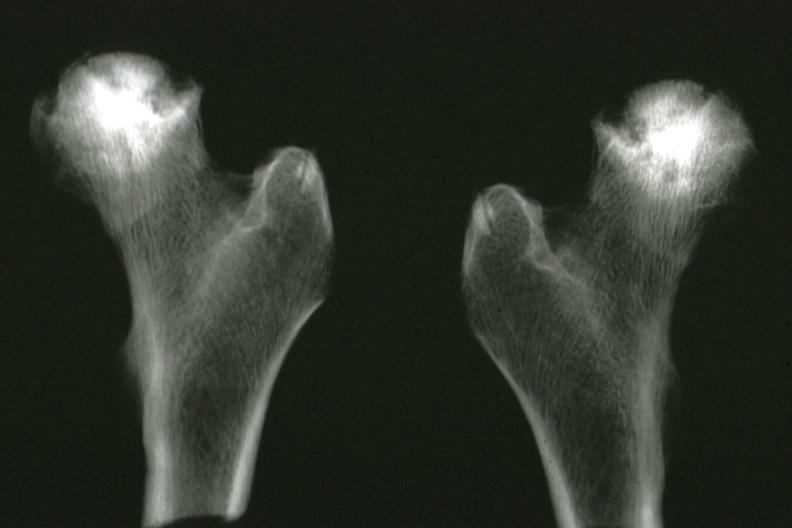s joints present?
Answer the question using a single word or phrase. Yes 